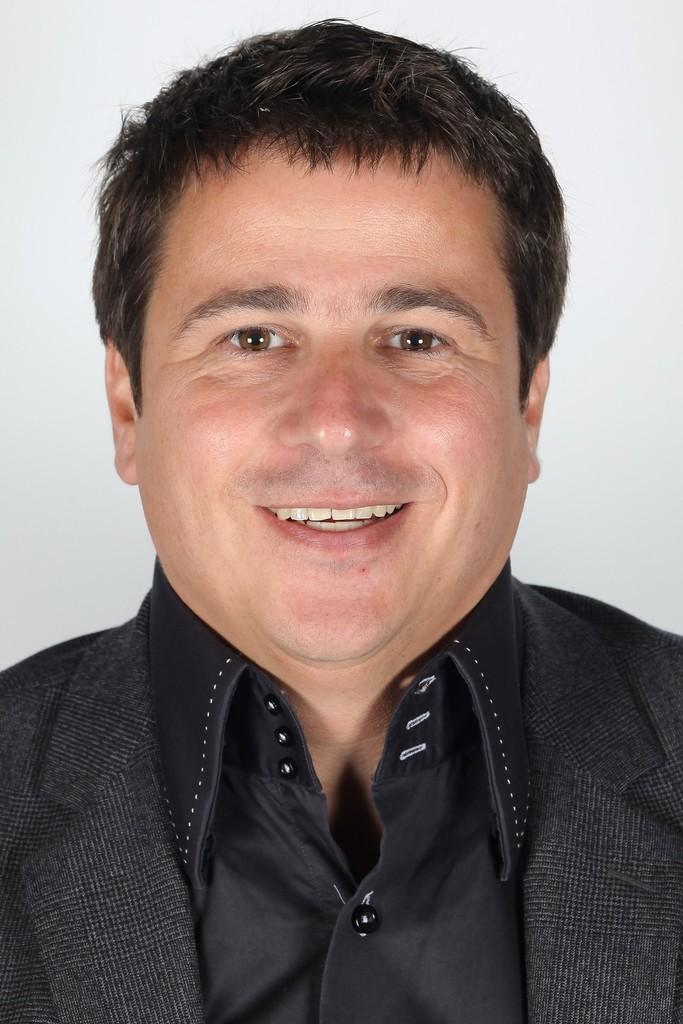Who is present in the image? There is a man in the picture. What is the man doing in the image? The man is standing in the image. What expression does the man have? The man is smiling in the image. What color is the man's coat? The man is wearing a black coat. What color is the man's shirt? The man is wearing a black shirt. What can be seen in the background of the image? There is a white surface in the background of the picture. What type of stone can be seen in the lunchroom in the image? There is no lunchroom or stone present in the image; it features a man standing and smiling while wearing a black coat and shirt. 